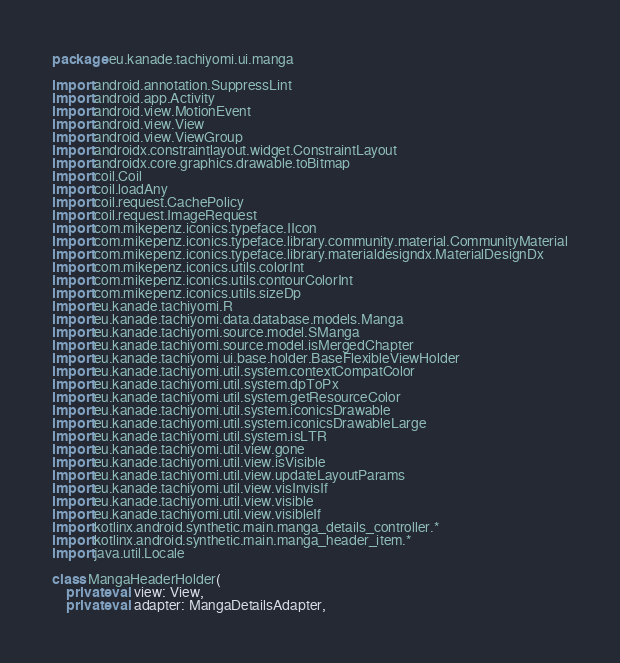Convert code to text. <code><loc_0><loc_0><loc_500><loc_500><_Kotlin_>package eu.kanade.tachiyomi.ui.manga

import android.annotation.SuppressLint
import android.app.Activity
import android.view.MotionEvent
import android.view.View
import android.view.ViewGroup
import androidx.constraintlayout.widget.ConstraintLayout
import androidx.core.graphics.drawable.toBitmap
import coil.Coil
import coil.loadAny
import coil.request.CachePolicy
import coil.request.ImageRequest
import com.mikepenz.iconics.typeface.IIcon
import com.mikepenz.iconics.typeface.library.community.material.CommunityMaterial
import com.mikepenz.iconics.typeface.library.materialdesigndx.MaterialDesignDx
import com.mikepenz.iconics.utils.colorInt
import com.mikepenz.iconics.utils.contourColorInt
import com.mikepenz.iconics.utils.sizeDp
import eu.kanade.tachiyomi.R
import eu.kanade.tachiyomi.data.database.models.Manga
import eu.kanade.tachiyomi.source.model.SManga
import eu.kanade.tachiyomi.source.model.isMergedChapter
import eu.kanade.tachiyomi.ui.base.holder.BaseFlexibleViewHolder
import eu.kanade.tachiyomi.util.system.contextCompatColor
import eu.kanade.tachiyomi.util.system.dpToPx
import eu.kanade.tachiyomi.util.system.getResourceColor
import eu.kanade.tachiyomi.util.system.iconicsDrawable
import eu.kanade.tachiyomi.util.system.iconicsDrawableLarge
import eu.kanade.tachiyomi.util.system.isLTR
import eu.kanade.tachiyomi.util.view.gone
import eu.kanade.tachiyomi.util.view.isVisible
import eu.kanade.tachiyomi.util.view.updateLayoutParams
import eu.kanade.tachiyomi.util.view.visInvisIf
import eu.kanade.tachiyomi.util.view.visible
import eu.kanade.tachiyomi.util.view.visibleIf
import kotlinx.android.synthetic.main.manga_details_controller.*
import kotlinx.android.synthetic.main.manga_header_item.*
import java.util.Locale

class MangaHeaderHolder(
    private val view: View,
    private val adapter: MangaDetailsAdapter,</code> 